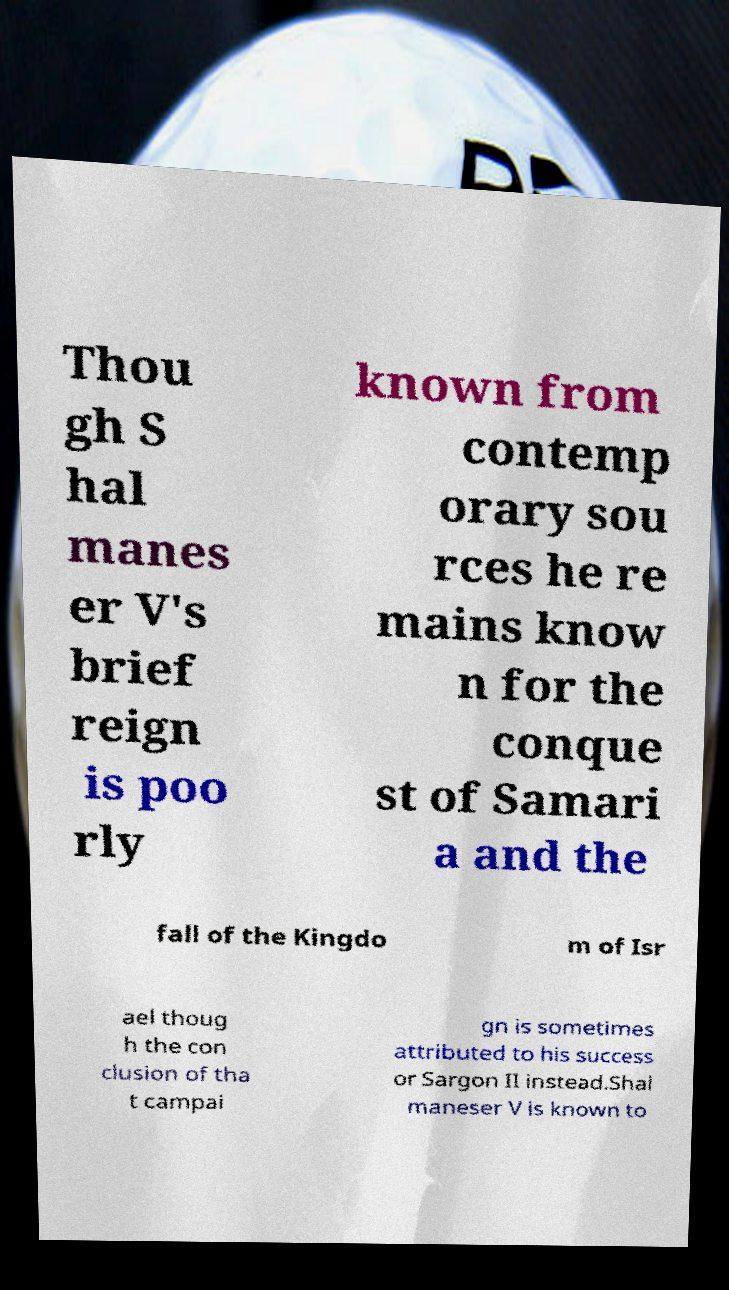Can you read and provide the text displayed in the image?This photo seems to have some interesting text. Can you extract and type it out for me? Thou gh S hal manes er V's brief reign is poo rly known from contemp orary sou rces he re mains know n for the conque st of Samari a and the fall of the Kingdo m of Isr ael thoug h the con clusion of tha t campai gn is sometimes attributed to his success or Sargon II instead.Shal maneser V is known to 